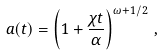Convert formula to latex. <formula><loc_0><loc_0><loc_500><loc_500>a ( t ) = \left ( 1 + \frac { \chi t } { \alpha } \right ) ^ { \omega + 1 / 2 } \, ,</formula> 